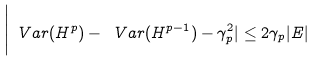<formula> <loc_0><loc_0><loc_500><loc_500>\Big | \ V a r ( H ^ { p } ) - \ V a r ( H ^ { p - 1 } ) - \gamma _ { p } ^ { 2 } | \leq 2 \gamma _ { p } | E |</formula> 